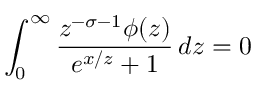Convert formula to latex. <formula><loc_0><loc_0><loc_500><loc_500>\int _ { 0 } ^ { \infty } { \frac { z ^ { - \sigma - 1 } \phi ( z ) } { { e ^ { x / z } } + 1 } } \, d z = 0</formula> 